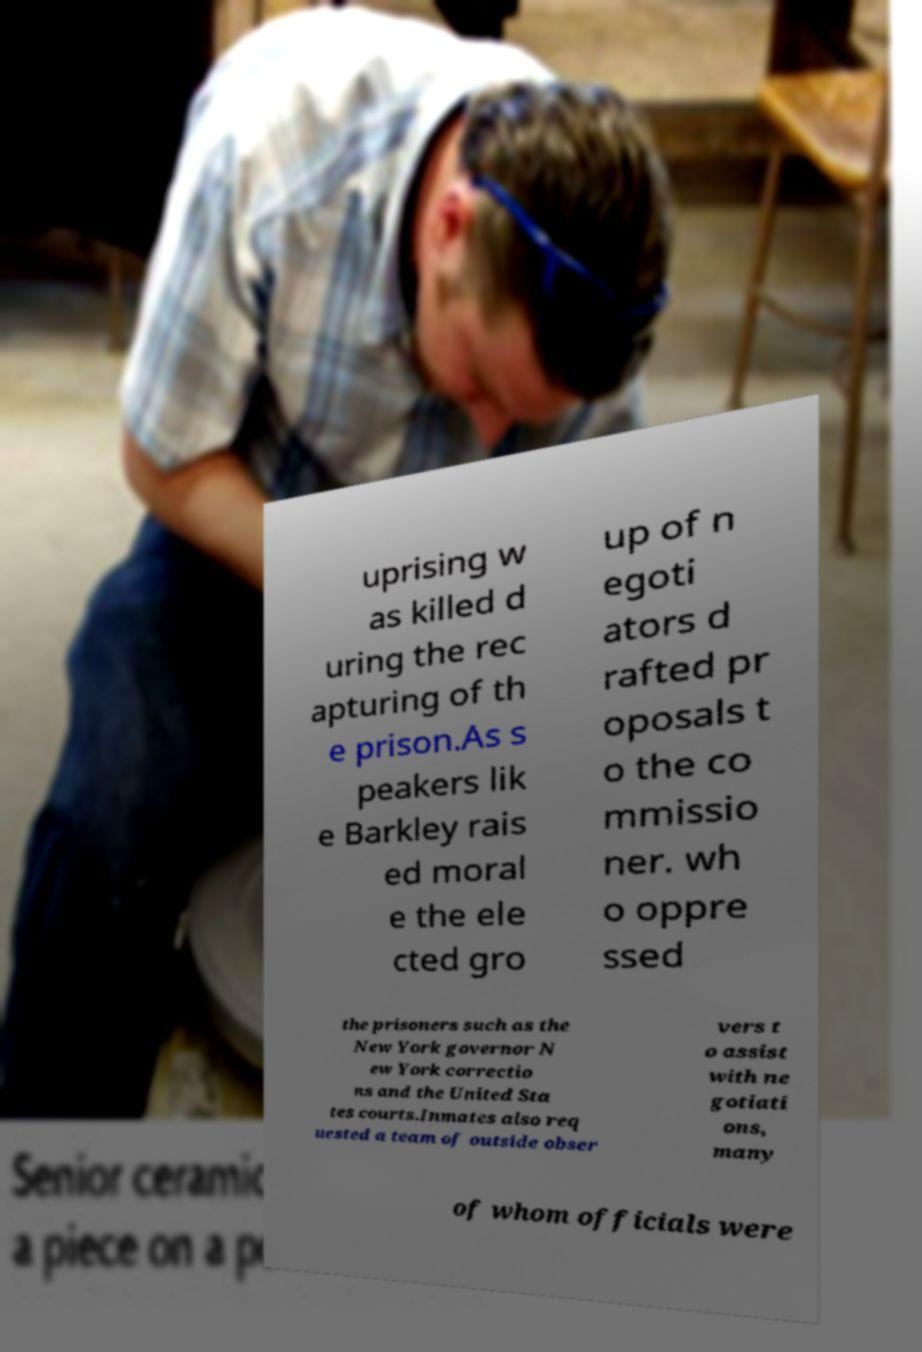Could you assist in decoding the text presented in this image and type it out clearly? uprising w as killed d uring the rec apturing of th e prison.As s peakers lik e Barkley rais ed moral e the ele cted gro up of n egoti ators d rafted pr oposals t o the co mmissio ner. wh o oppre ssed the prisoners such as the New York governor N ew York correctio ns and the United Sta tes courts.Inmates also req uested a team of outside obser vers t o assist with ne gotiati ons, many of whom officials were 